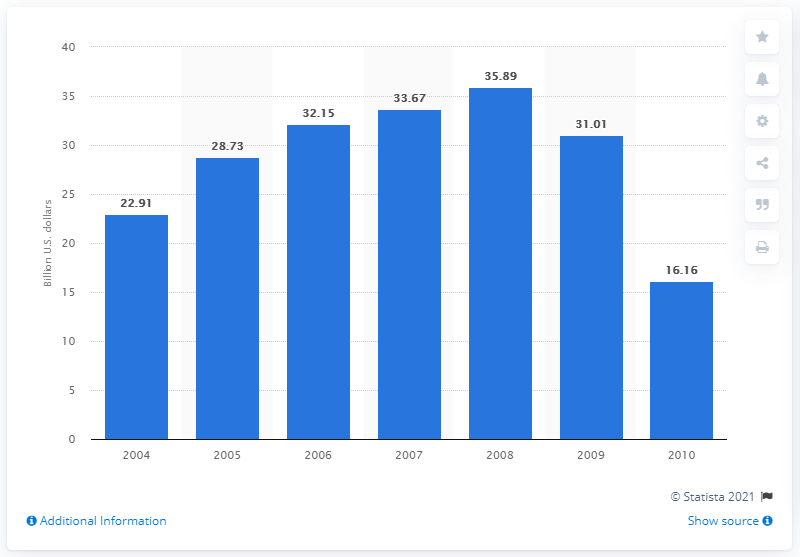Indicate a few pertinent items in this graphic. In 2006, the total revenues generated by the transportation-related activities of the U.S. airline industry amounted to 32.15 billion U.S. dollars. 